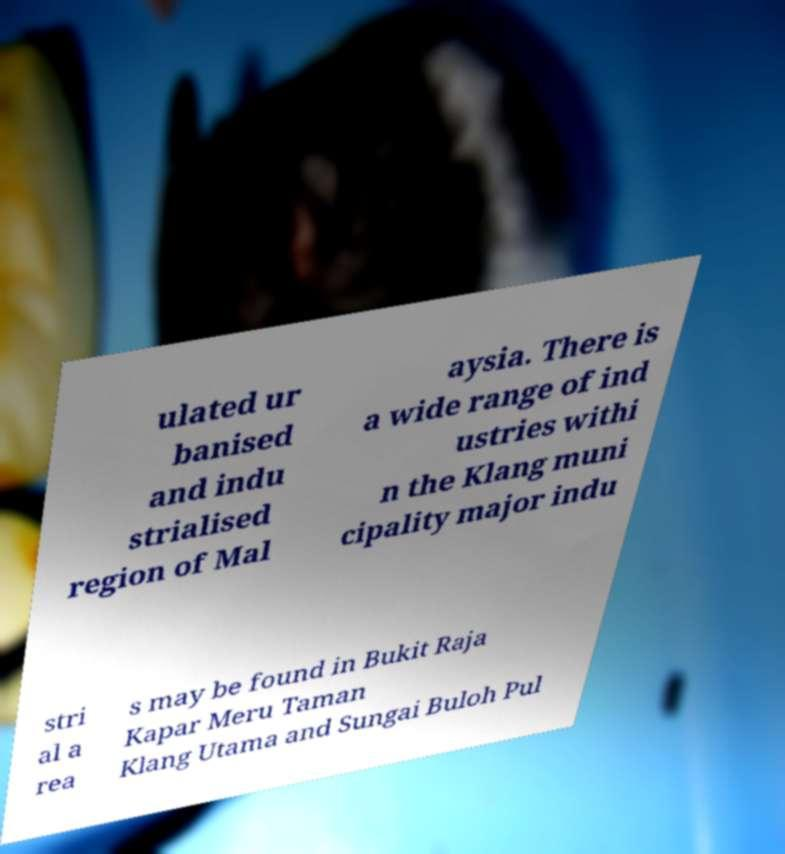Please identify and transcribe the text found in this image. ulated ur banised and indu strialised region of Mal aysia. There is a wide range of ind ustries withi n the Klang muni cipality major indu stri al a rea s may be found in Bukit Raja Kapar Meru Taman Klang Utama and Sungai Buloh Pul 